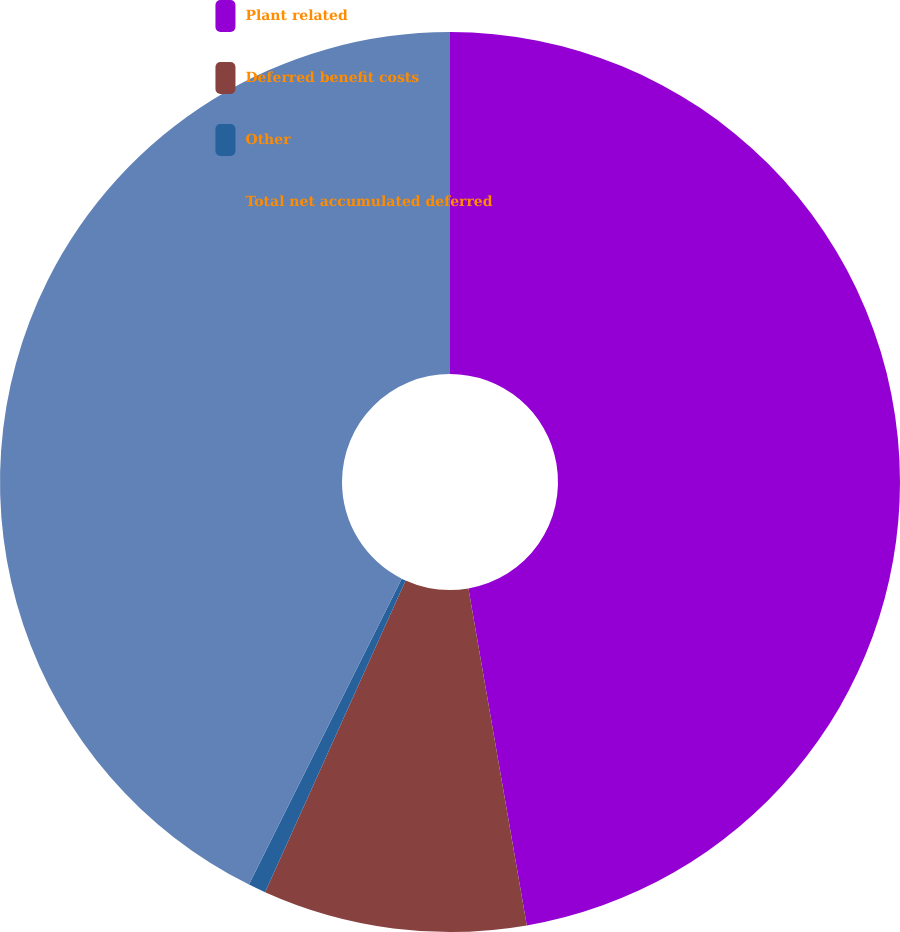<chart> <loc_0><loc_0><loc_500><loc_500><pie_chart><fcel>Plant related<fcel>Deferred benefit costs<fcel>Other<fcel>Total net accumulated deferred<nl><fcel>47.27%<fcel>9.47%<fcel>0.63%<fcel>42.63%<nl></chart> 